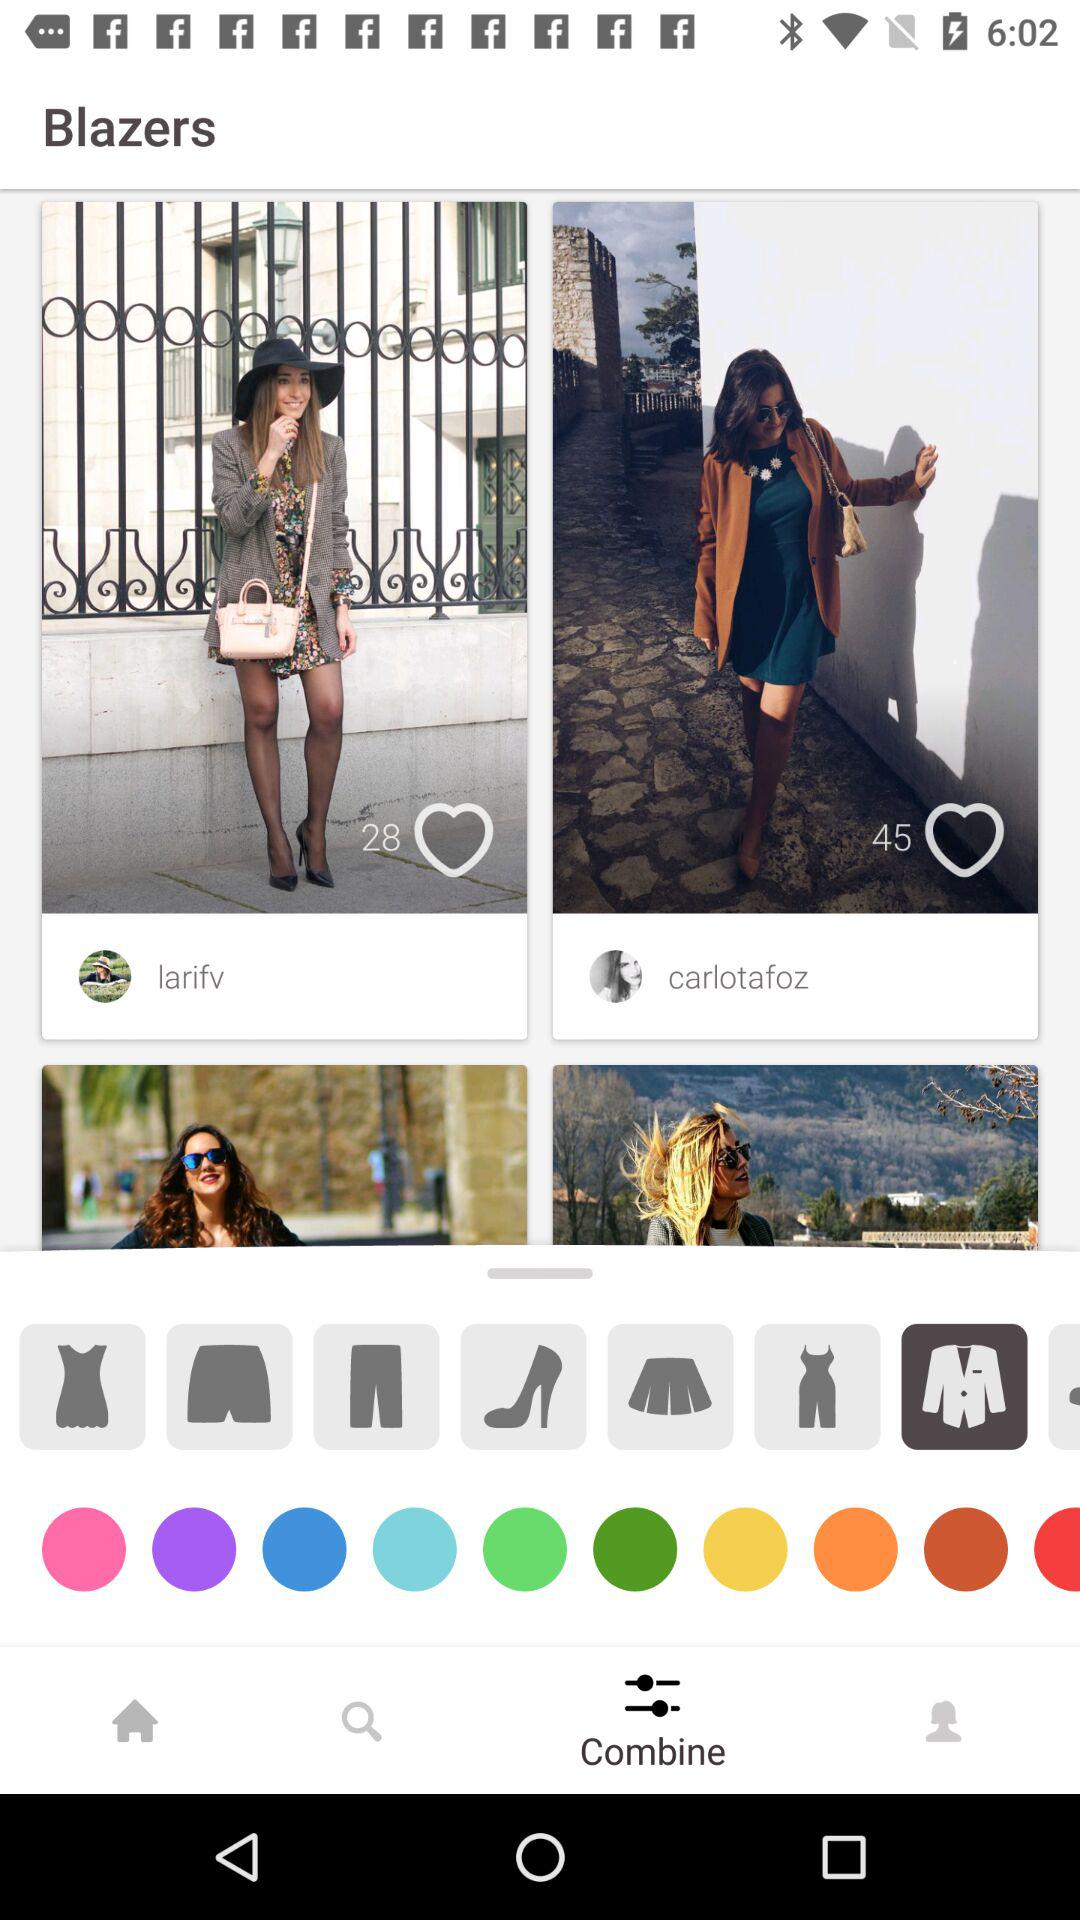How many likes are there of Carlotafoz's photo? There are 45 likes of Carlotafoz's photo. 